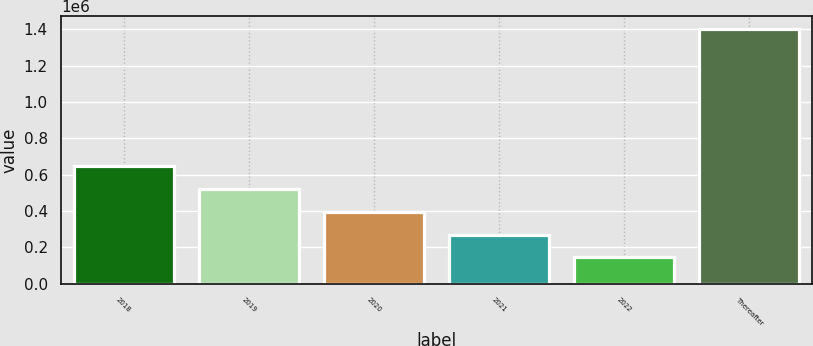Convert chart to OTSL. <chart><loc_0><loc_0><loc_500><loc_500><bar_chart><fcel>2018<fcel>2019<fcel>2020<fcel>2021<fcel>2022<fcel>Thereafter<nl><fcel>646374<fcel>520746<fcel>395118<fcel>269490<fcel>143862<fcel>1.40014e+06<nl></chart> 